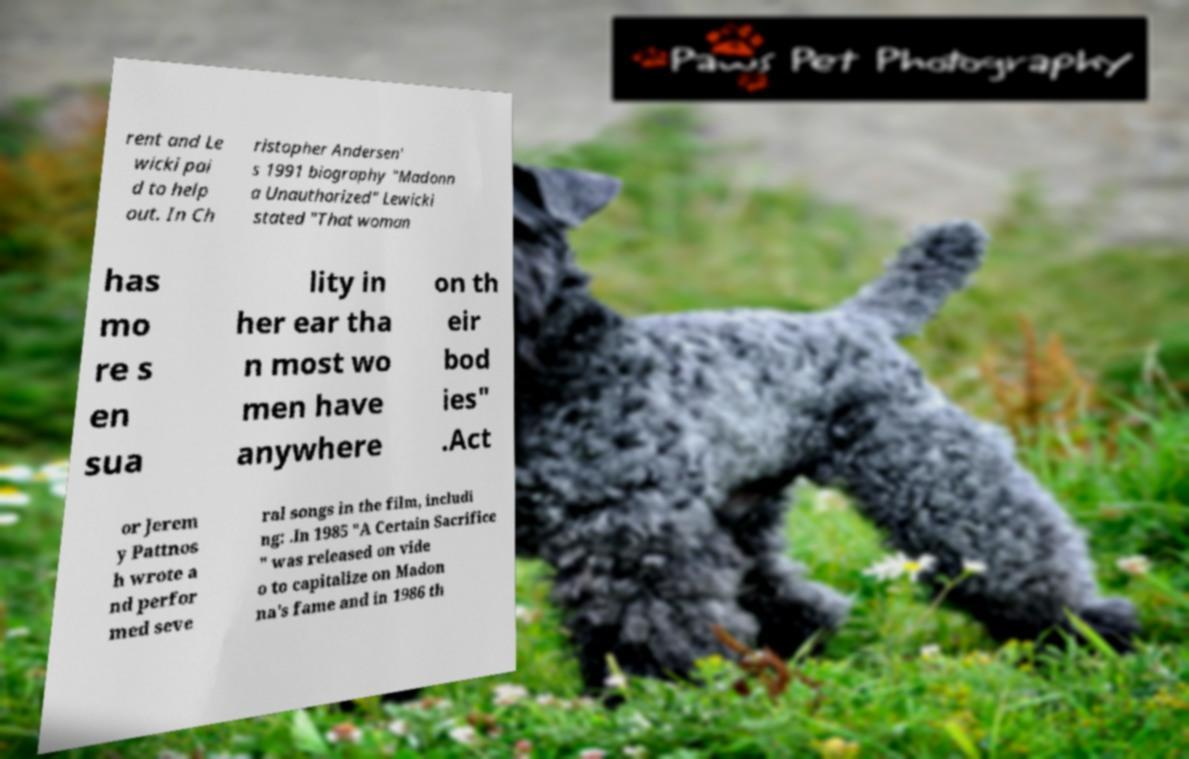Could you assist in decoding the text presented in this image and type it out clearly? rent and Le wicki pai d to help out. In Ch ristopher Andersen' s 1991 biography "Madonn a Unauthorized" Lewicki stated "That woman has mo re s en sua lity in her ear tha n most wo men have anywhere on th eir bod ies" .Act or Jerem y Pattnos h wrote a nd perfor med seve ral songs in the film, includi ng: .In 1985 "A Certain Sacrifice " was released on vide o to capitalize on Madon na's fame and in 1986 th 